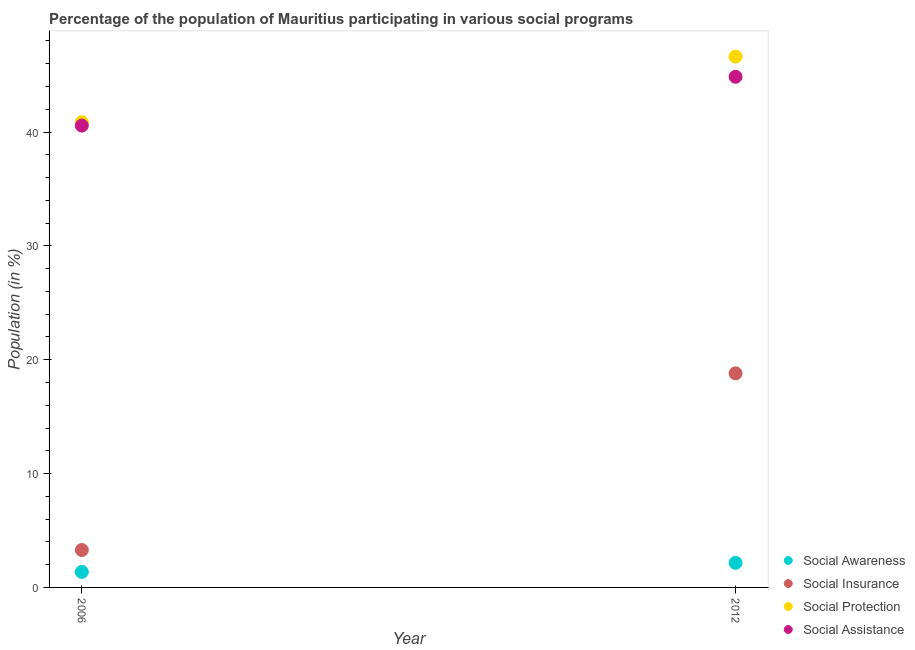Is the number of dotlines equal to the number of legend labels?
Your answer should be very brief. Yes. What is the participation of population in social insurance programs in 2012?
Keep it short and to the point. 18.8. Across all years, what is the maximum participation of population in social awareness programs?
Ensure brevity in your answer.  2.16. Across all years, what is the minimum participation of population in social insurance programs?
Your answer should be very brief. 3.29. In which year was the participation of population in social assistance programs minimum?
Your answer should be very brief. 2006. What is the total participation of population in social awareness programs in the graph?
Your answer should be compact. 3.52. What is the difference between the participation of population in social insurance programs in 2006 and that in 2012?
Keep it short and to the point. -15.52. What is the difference between the participation of population in social assistance programs in 2006 and the participation of population in social protection programs in 2012?
Offer a very short reply. -6.06. What is the average participation of population in social protection programs per year?
Your answer should be compact. 43.75. In the year 2006, what is the difference between the participation of population in social protection programs and participation of population in social assistance programs?
Provide a short and direct response. 0.3. What is the ratio of the participation of population in social protection programs in 2006 to that in 2012?
Your response must be concise. 0.88. Is it the case that in every year, the sum of the participation of population in social assistance programs and participation of population in social insurance programs is greater than the sum of participation of population in social protection programs and participation of population in social awareness programs?
Your response must be concise. No. Is it the case that in every year, the sum of the participation of population in social awareness programs and participation of population in social insurance programs is greater than the participation of population in social protection programs?
Ensure brevity in your answer.  No. Is the participation of population in social protection programs strictly greater than the participation of population in social assistance programs over the years?
Make the answer very short. Yes. How many dotlines are there?
Provide a short and direct response. 4. How many years are there in the graph?
Your response must be concise. 2. Does the graph contain grids?
Keep it short and to the point. No. Where does the legend appear in the graph?
Make the answer very short. Bottom right. How are the legend labels stacked?
Your answer should be very brief. Vertical. What is the title of the graph?
Make the answer very short. Percentage of the population of Mauritius participating in various social programs . What is the label or title of the X-axis?
Offer a terse response. Year. What is the label or title of the Y-axis?
Provide a succinct answer. Population (in %). What is the Population (in %) in Social Awareness in 2006?
Keep it short and to the point. 1.36. What is the Population (in %) in Social Insurance in 2006?
Your answer should be very brief. 3.29. What is the Population (in %) in Social Protection in 2006?
Keep it short and to the point. 40.87. What is the Population (in %) in Social Assistance in 2006?
Ensure brevity in your answer.  40.57. What is the Population (in %) of Social Awareness in 2012?
Offer a very short reply. 2.16. What is the Population (in %) in Social Insurance in 2012?
Offer a very short reply. 18.8. What is the Population (in %) in Social Protection in 2012?
Your answer should be compact. 46.63. What is the Population (in %) of Social Assistance in 2012?
Make the answer very short. 44.85. Across all years, what is the maximum Population (in %) of Social Awareness?
Provide a succinct answer. 2.16. Across all years, what is the maximum Population (in %) in Social Insurance?
Provide a succinct answer. 18.8. Across all years, what is the maximum Population (in %) of Social Protection?
Provide a short and direct response. 46.63. Across all years, what is the maximum Population (in %) of Social Assistance?
Offer a terse response. 44.85. Across all years, what is the minimum Population (in %) in Social Awareness?
Give a very brief answer. 1.36. Across all years, what is the minimum Population (in %) of Social Insurance?
Offer a very short reply. 3.29. Across all years, what is the minimum Population (in %) in Social Protection?
Make the answer very short. 40.87. Across all years, what is the minimum Population (in %) of Social Assistance?
Your response must be concise. 40.57. What is the total Population (in %) of Social Awareness in the graph?
Ensure brevity in your answer.  3.52. What is the total Population (in %) in Social Insurance in the graph?
Keep it short and to the point. 22.09. What is the total Population (in %) of Social Protection in the graph?
Provide a succinct answer. 87.49. What is the total Population (in %) in Social Assistance in the graph?
Provide a succinct answer. 85.42. What is the difference between the Population (in %) in Social Awareness in 2006 and that in 2012?
Your answer should be compact. -0.8. What is the difference between the Population (in %) of Social Insurance in 2006 and that in 2012?
Your response must be concise. -15.52. What is the difference between the Population (in %) in Social Protection in 2006 and that in 2012?
Make the answer very short. -5.76. What is the difference between the Population (in %) of Social Assistance in 2006 and that in 2012?
Your answer should be very brief. -4.29. What is the difference between the Population (in %) of Social Awareness in 2006 and the Population (in %) of Social Insurance in 2012?
Provide a succinct answer. -17.44. What is the difference between the Population (in %) of Social Awareness in 2006 and the Population (in %) of Social Protection in 2012?
Give a very brief answer. -45.26. What is the difference between the Population (in %) in Social Awareness in 2006 and the Population (in %) in Social Assistance in 2012?
Provide a succinct answer. -43.49. What is the difference between the Population (in %) in Social Insurance in 2006 and the Population (in %) in Social Protection in 2012?
Your answer should be very brief. -43.34. What is the difference between the Population (in %) in Social Insurance in 2006 and the Population (in %) in Social Assistance in 2012?
Provide a succinct answer. -41.57. What is the difference between the Population (in %) in Social Protection in 2006 and the Population (in %) in Social Assistance in 2012?
Offer a very short reply. -3.99. What is the average Population (in %) of Social Awareness per year?
Your answer should be very brief. 1.76. What is the average Population (in %) of Social Insurance per year?
Your answer should be compact. 11.05. What is the average Population (in %) of Social Protection per year?
Your answer should be very brief. 43.75. What is the average Population (in %) of Social Assistance per year?
Provide a succinct answer. 42.71. In the year 2006, what is the difference between the Population (in %) in Social Awareness and Population (in %) in Social Insurance?
Give a very brief answer. -1.92. In the year 2006, what is the difference between the Population (in %) in Social Awareness and Population (in %) in Social Protection?
Give a very brief answer. -39.51. In the year 2006, what is the difference between the Population (in %) of Social Awareness and Population (in %) of Social Assistance?
Your answer should be very brief. -39.2. In the year 2006, what is the difference between the Population (in %) of Social Insurance and Population (in %) of Social Protection?
Make the answer very short. -37.58. In the year 2006, what is the difference between the Population (in %) in Social Insurance and Population (in %) in Social Assistance?
Offer a terse response. -37.28. In the year 2006, what is the difference between the Population (in %) of Social Protection and Population (in %) of Social Assistance?
Make the answer very short. 0.3. In the year 2012, what is the difference between the Population (in %) of Social Awareness and Population (in %) of Social Insurance?
Your answer should be compact. -16.64. In the year 2012, what is the difference between the Population (in %) of Social Awareness and Population (in %) of Social Protection?
Offer a very short reply. -44.47. In the year 2012, what is the difference between the Population (in %) of Social Awareness and Population (in %) of Social Assistance?
Provide a short and direct response. -42.69. In the year 2012, what is the difference between the Population (in %) in Social Insurance and Population (in %) in Social Protection?
Keep it short and to the point. -27.82. In the year 2012, what is the difference between the Population (in %) of Social Insurance and Population (in %) of Social Assistance?
Ensure brevity in your answer.  -26.05. In the year 2012, what is the difference between the Population (in %) of Social Protection and Population (in %) of Social Assistance?
Offer a very short reply. 1.77. What is the ratio of the Population (in %) of Social Awareness in 2006 to that in 2012?
Offer a very short reply. 0.63. What is the ratio of the Population (in %) of Social Insurance in 2006 to that in 2012?
Make the answer very short. 0.17. What is the ratio of the Population (in %) in Social Protection in 2006 to that in 2012?
Ensure brevity in your answer.  0.88. What is the ratio of the Population (in %) in Social Assistance in 2006 to that in 2012?
Give a very brief answer. 0.9. What is the difference between the highest and the second highest Population (in %) of Social Awareness?
Offer a very short reply. 0.8. What is the difference between the highest and the second highest Population (in %) in Social Insurance?
Give a very brief answer. 15.52. What is the difference between the highest and the second highest Population (in %) in Social Protection?
Your answer should be very brief. 5.76. What is the difference between the highest and the second highest Population (in %) in Social Assistance?
Your answer should be very brief. 4.29. What is the difference between the highest and the lowest Population (in %) in Social Awareness?
Ensure brevity in your answer.  0.8. What is the difference between the highest and the lowest Population (in %) of Social Insurance?
Your answer should be compact. 15.52. What is the difference between the highest and the lowest Population (in %) of Social Protection?
Ensure brevity in your answer.  5.76. What is the difference between the highest and the lowest Population (in %) of Social Assistance?
Your answer should be compact. 4.29. 